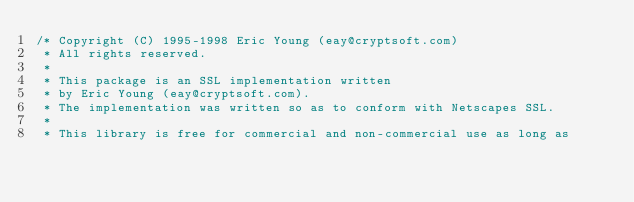<code> <loc_0><loc_0><loc_500><loc_500><_C_>/* Copyright (C) 1995-1998 Eric Young (eay@cryptsoft.com)
 * All rights reserved.
 *
 * This package is an SSL implementation written
 * by Eric Young (eay@cryptsoft.com).
 * The implementation was written so as to conform with Netscapes SSL.
 *
 * This library is free for commercial and non-commercial use as long as</code> 